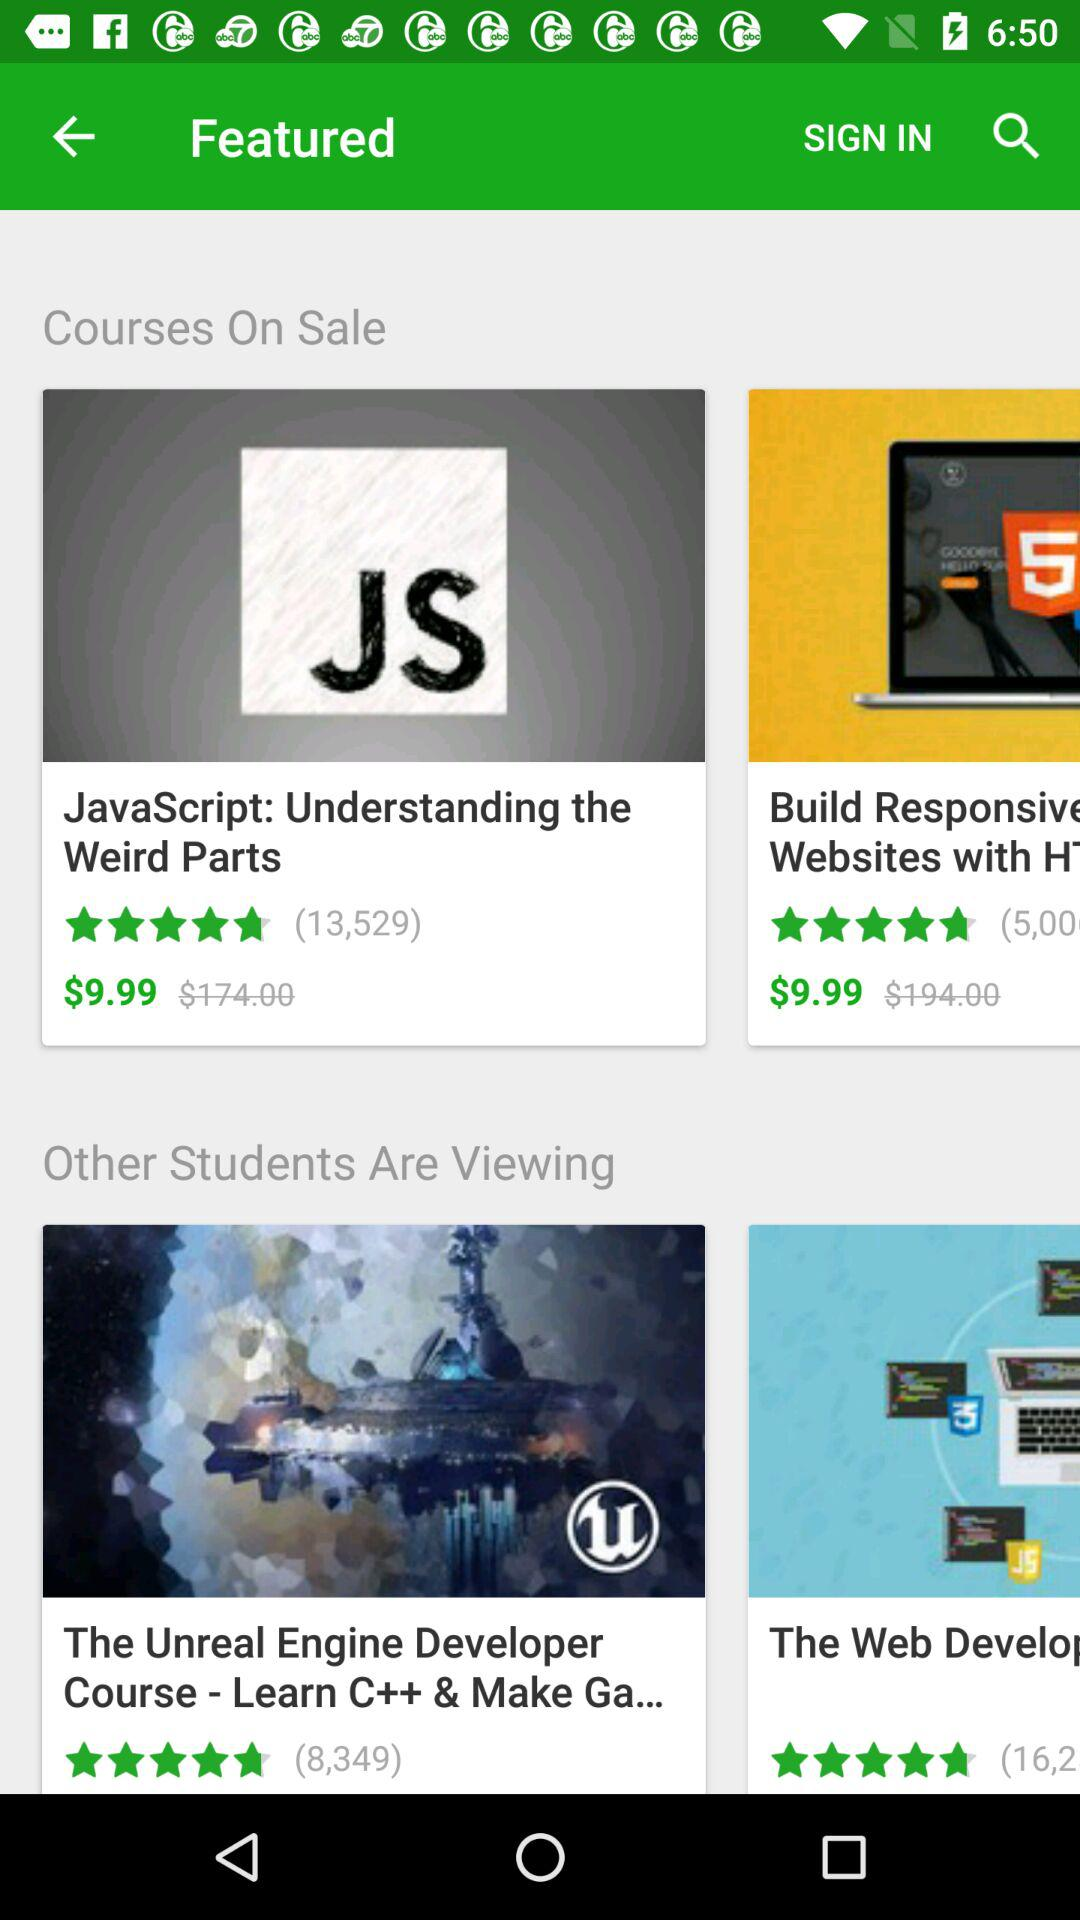What is the rating of the JavaScript? The rating is 4.4 stars. 